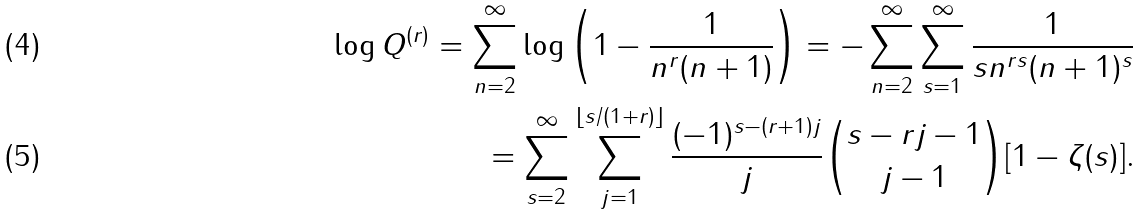Convert formula to latex. <formula><loc_0><loc_0><loc_500><loc_500>\log Q ^ { ( r ) } = \sum _ { n = 2 } ^ { \infty } \log \left ( 1 - \frac { 1 } { n ^ { r } ( n + 1 ) } \right ) = - \sum _ { n = 2 } ^ { \infty } \sum _ { s = 1 } ^ { \infty } \frac { 1 } { s n ^ { r s } ( n + 1 ) ^ { s } } \\ = \sum _ { s = 2 } ^ { \infty } \sum _ { j = 1 } ^ { \lfloor s / ( 1 + r ) \rfloor } \frac { ( - 1 ) ^ { s - ( r + 1 ) j } } { j } \binom { s - r j - 1 } { j - 1 } [ 1 - \zeta ( s ) ] .</formula> 